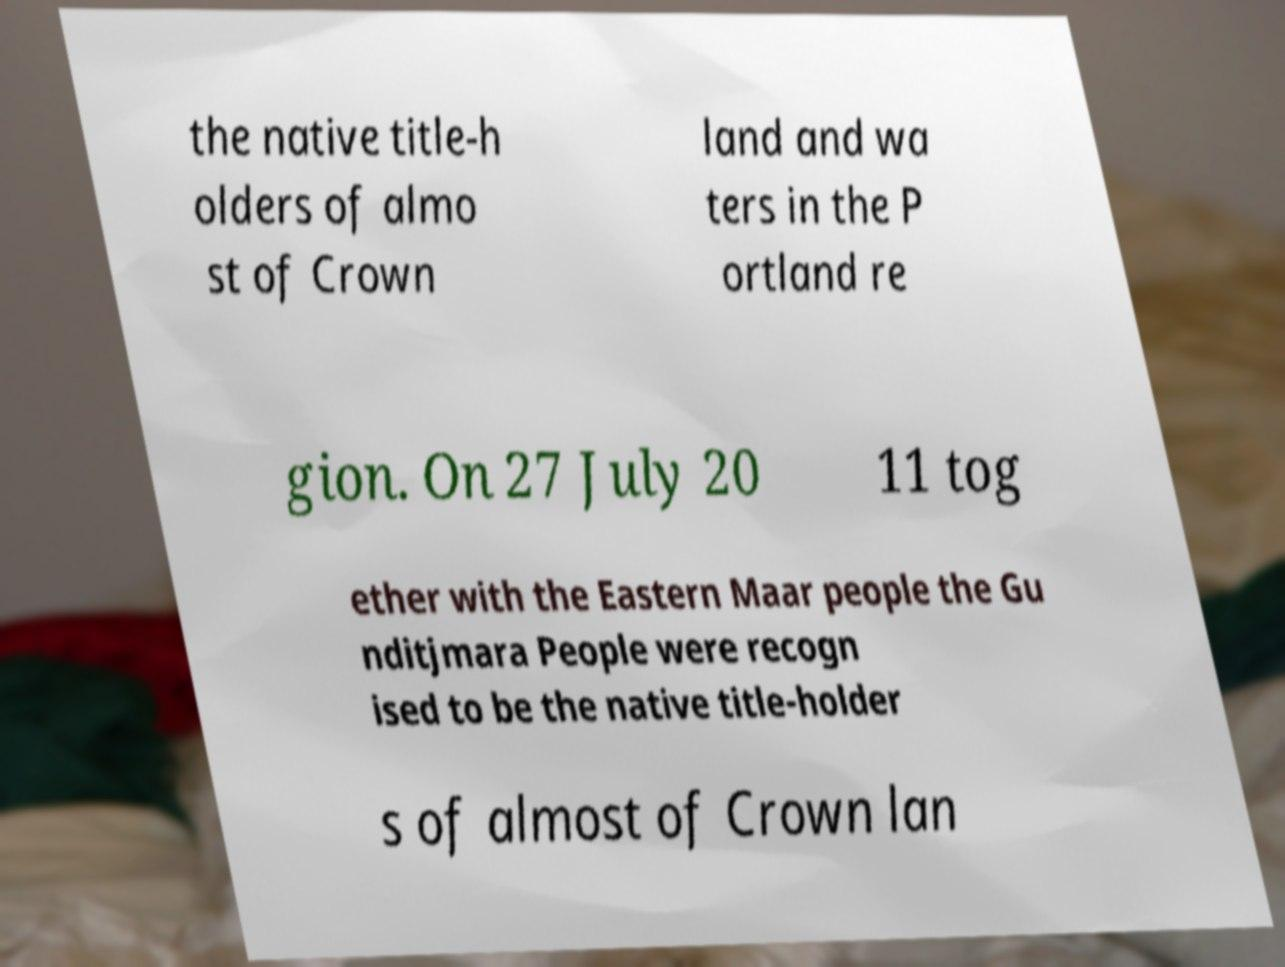For documentation purposes, I need the text within this image transcribed. Could you provide that? the native title-h olders of almo st of Crown land and wa ters in the P ortland re gion. On 27 July 20 11 tog ether with the Eastern Maar people the Gu nditjmara People were recogn ised to be the native title-holder s of almost of Crown lan 